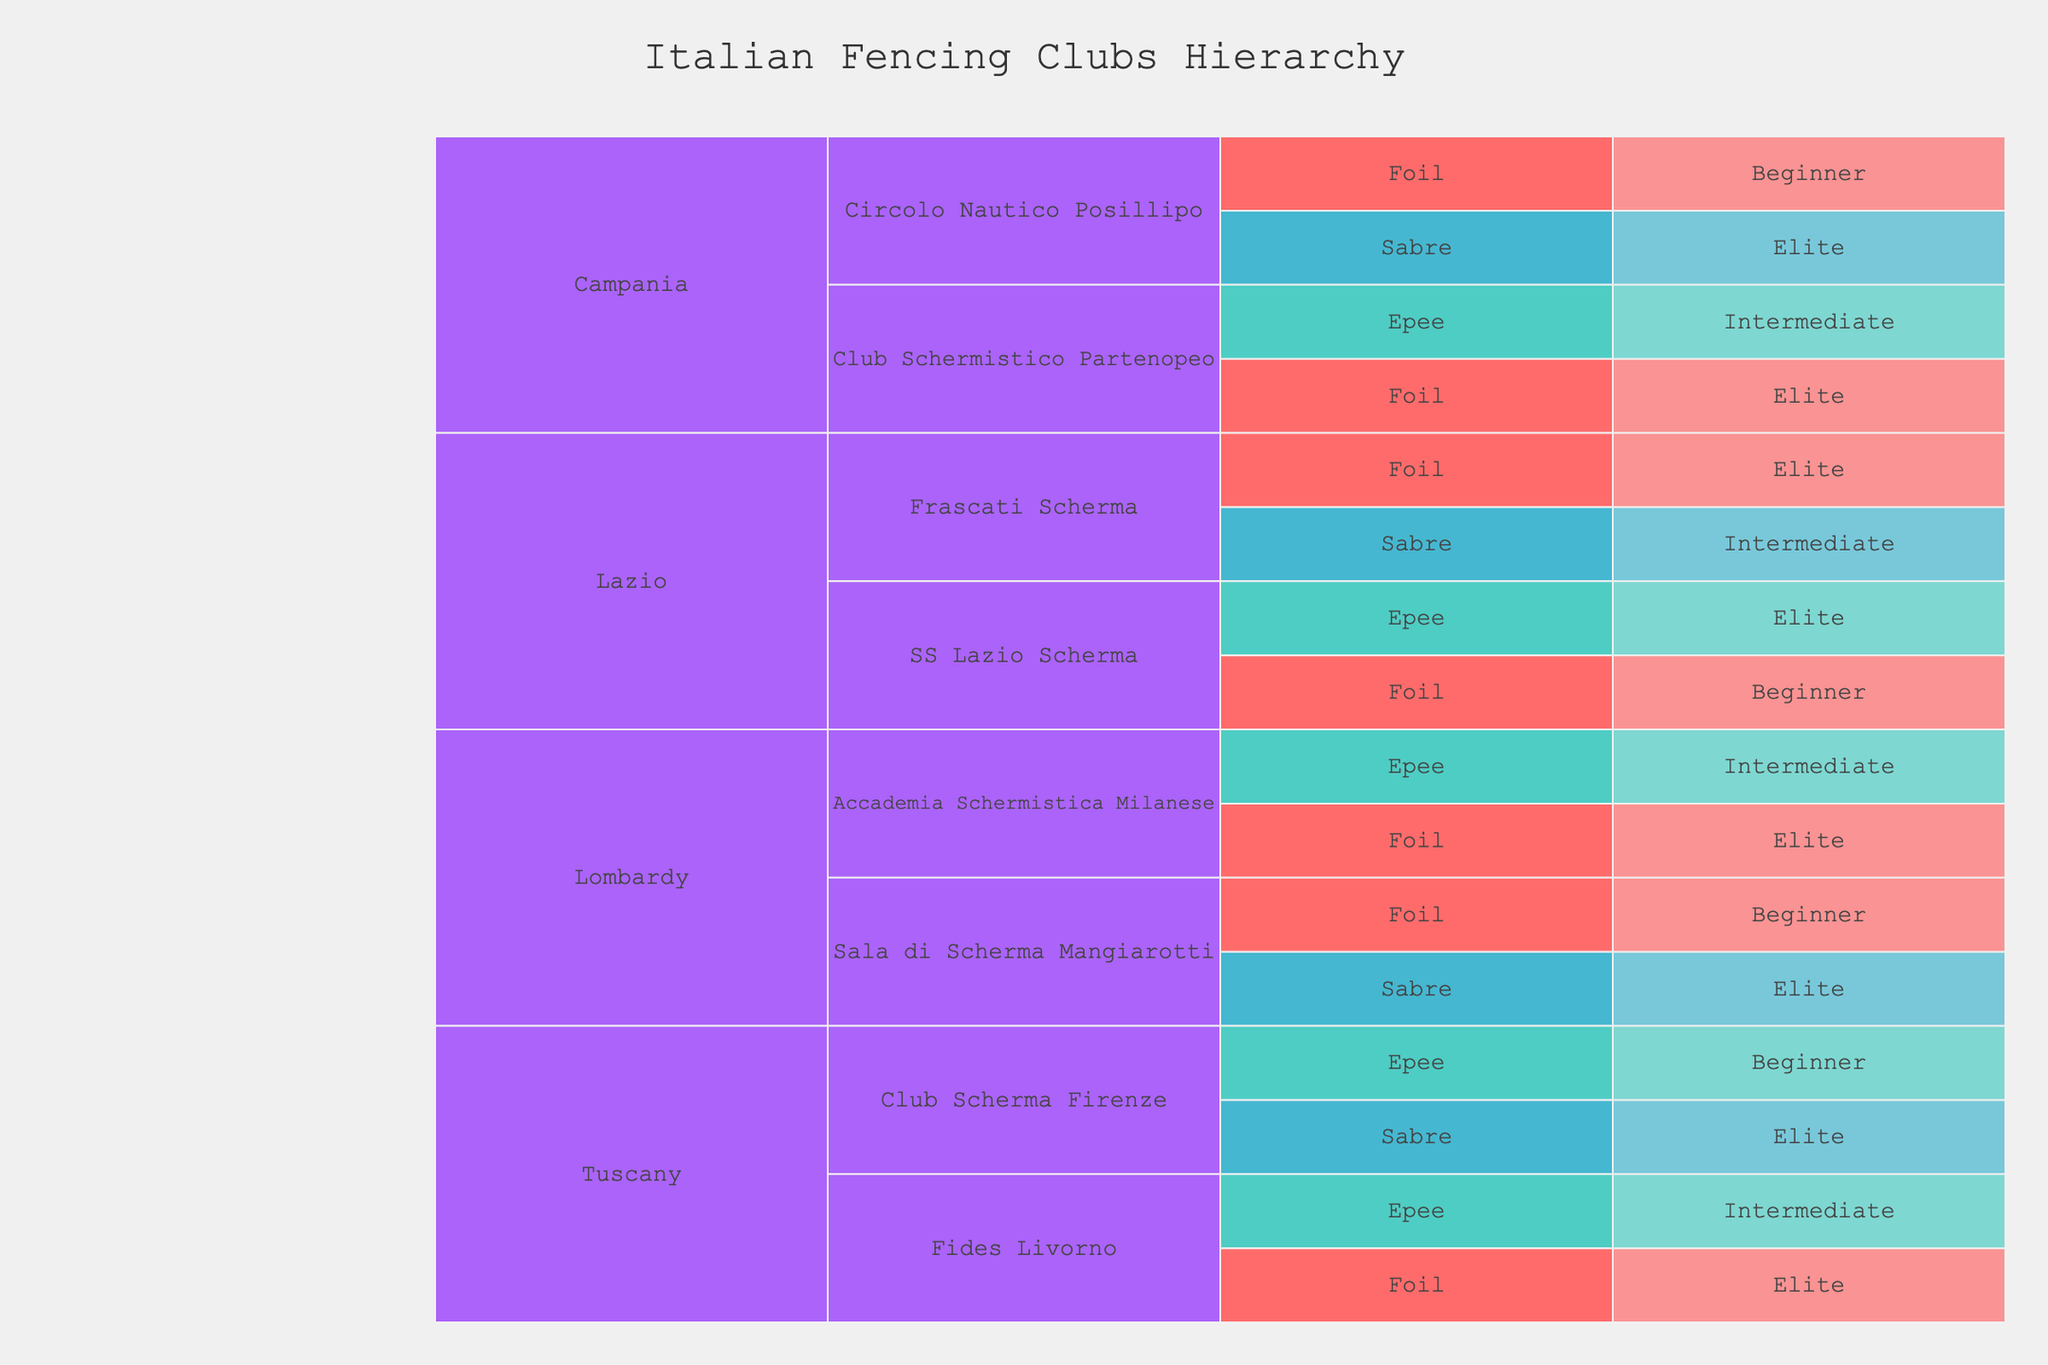How many regions have fencing clubs represented in the icicle chart? The icicle chart shows categories starting from regions. The top levels should list the number of distinct regions.
Answer: 4 Which club in Lombardy has the most specializations? In the Lombardy region, identify the clubs, then count the number of specializations under each.
Answer: Sala di Scherma Mangiarotti What specialization appears most frequently across all regions? Look at each specialization (Foil, Epee, Sabre) and count the occurrences across all regions. The one with the highest count is the most frequent.
Answer: Foil Which regional club has the most elite fencers? Identify clubs in each region, then count the number of elite level fencers in each club and compare.
Answer: Frascati Scherma (Lazio) How many elite-level clubs are there in Tuscany? Under the Tuscany region, count the number of clubs that have at least one specialization labeled as "Elite."
Answer: 2 What is the color representation for the Epee specialization in the chart? Refer to the chart legend or look at the color-coded specialization section to find the color representing Epee.
Answer: #4ECDC4 Compare the number of beginner-level fencers between Lombardy and Lazio. Which region has more? Count the number of beginner levels under Lombardy and Lazio, then compare the totals.
Answer: Lombardy Which specialization does Circolo Nautico Posillipo offer aside from Foil? Under the Campania region, locate Circolo Nautico Posillipo and identify the specializations listed there.
Answer: Sabre What is the total number of clubs listed in the icicle chart? Count all the club names listed under each region in the chart.
Answer: 8 Does any club provide all three specializations: Foil, Epee, and Sabre? Check each club under their respective regions to see if they have all three specializations.
Answer: No 